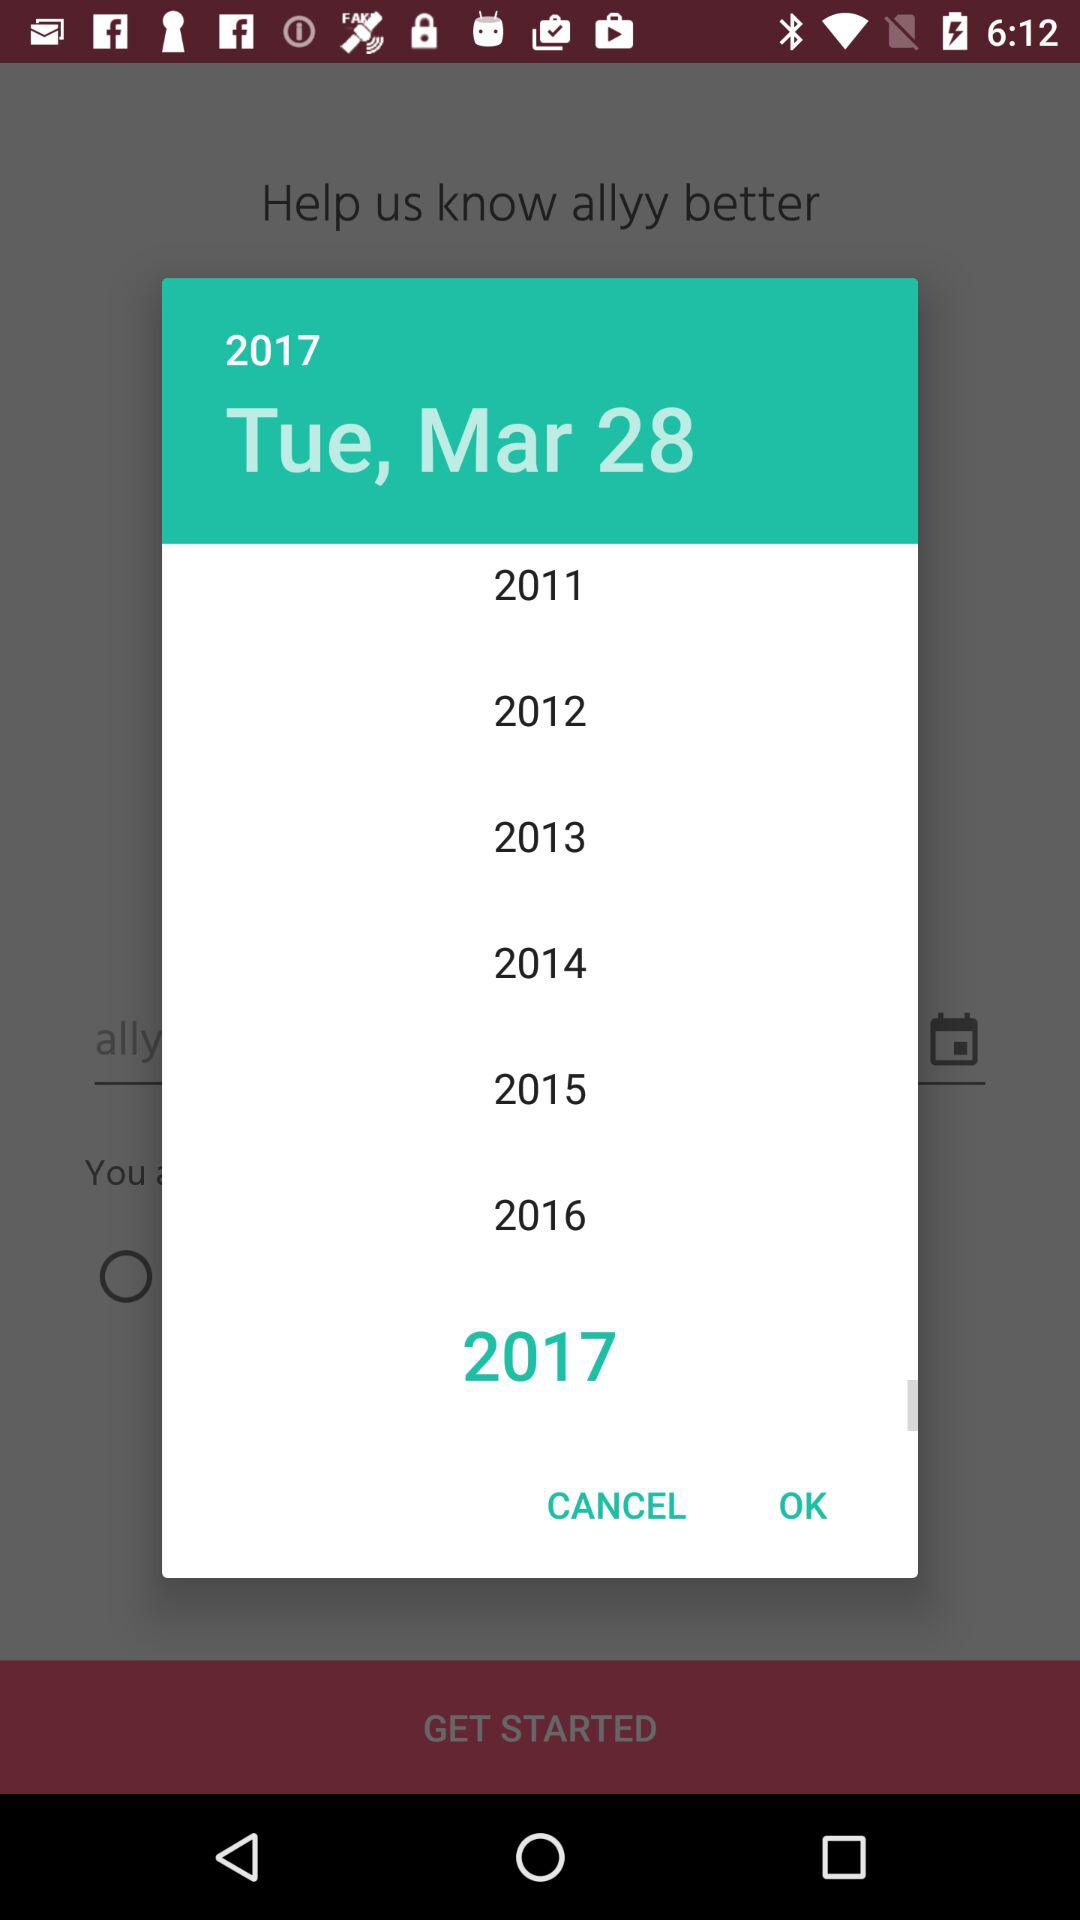What is the day? The day is Tuesday. 